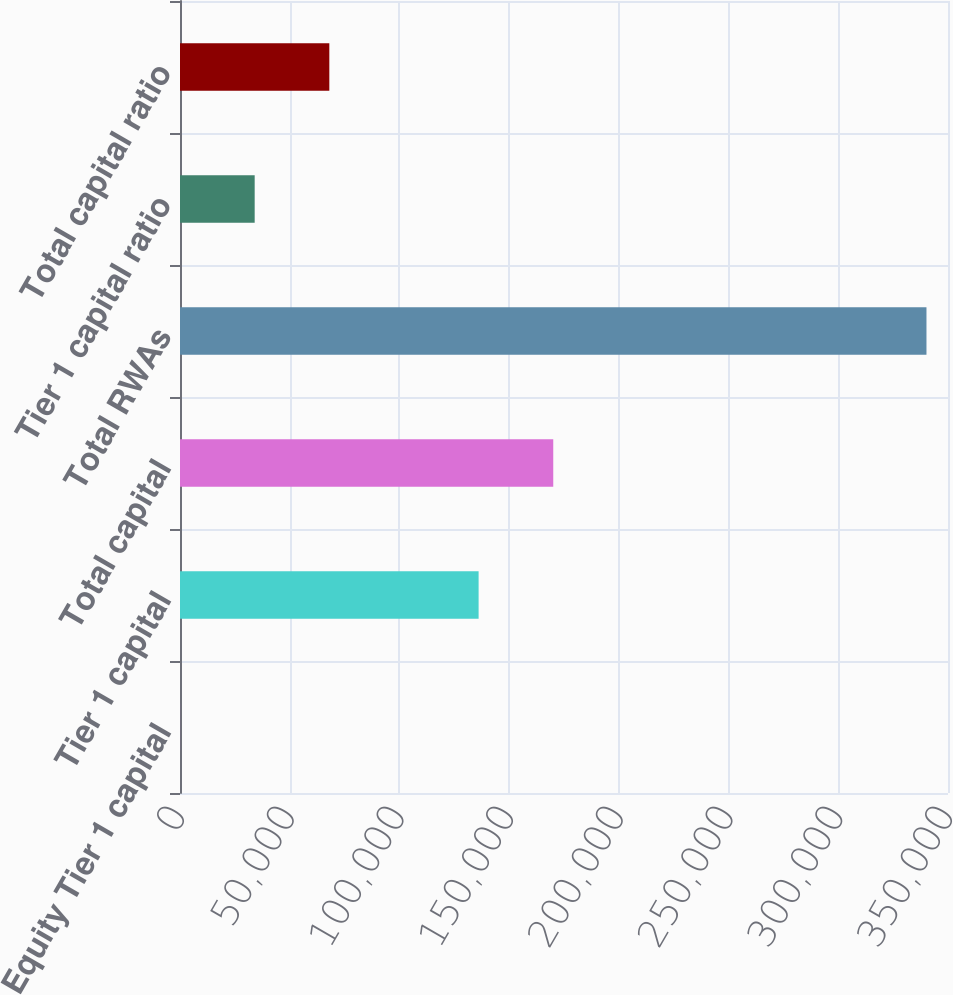Convert chart to OTSL. <chart><loc_0><loc_0><loc_500><loc_500><bar_chart><fcel>Common Equity Tier 1 capital<fcel>Tier 1 capital<fcel>Total capital<fcel>Total RWAs<fcel>Tier 1 capital ratio<fcel>Total capital ratio<nl><fcel>17.8<fcel>136087<fcel>170104<fcel>340191<fcel>34035.1<fcel>68052.4<nl></chart> 